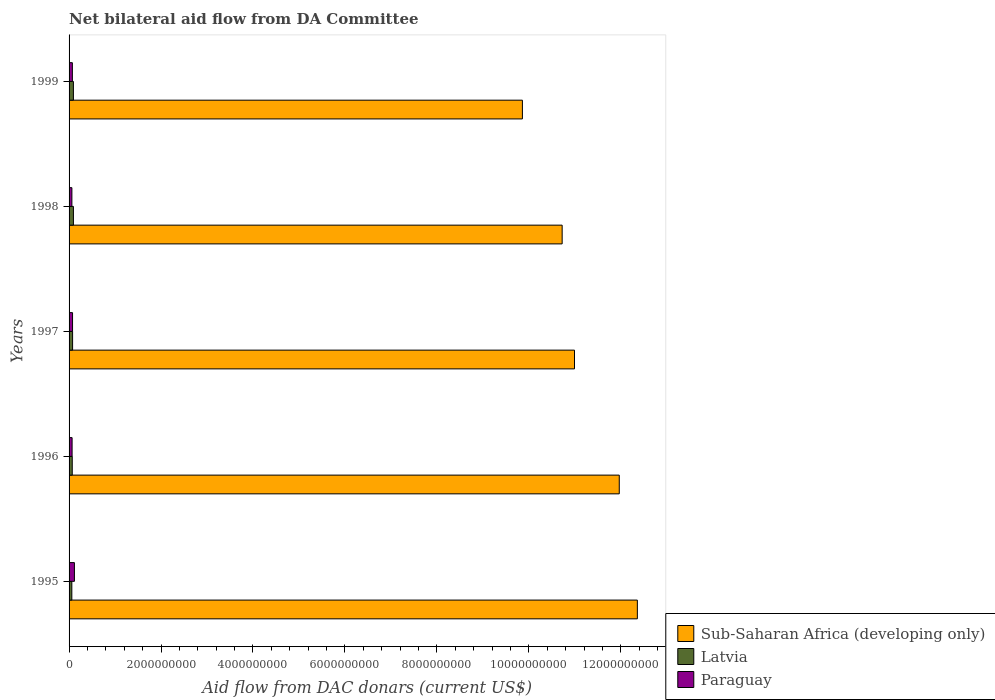How many different coloured bars are there?
Keep it short and to the point. 3. How many groups of bars are there?
Provide a short and direct response. 5. Are the number of bars on each tick of the Y-axis equal?
Your answer should be very brief. Yes. How many bars are there on the 3rd tick from the top?
Provide a short and direct response. 3. How many bars are there on the 1st tick from the bottom?
Your answer should be compact. 3. What is the aid flow in in Paraguay in 1998?
Make the answer very short. 6.14e+07. Across all years, what is the maximum aid flow in in Latvia?
Your answer should be compact. 9.46e+07. Across all years, what is the minimum aid flow in in Paraguay?
Make the answer very short. 6.14e+07. In which year was the aid flow in in Sub-Saharan Africa (developing only) maximum?
Offer a very short reply. 1995. In which year was the aid flow in in Sub-Saharan Africa (developing only) minimum?
Provide a succinct answer. 1999. What is the total aid flow in in Paraguay in the graph?
Give a very brief answer. 3.91e+08. What is the difference between the aid flow in in Paraguay in 1995 and that in 1997?
Offer a terse response. 4.06e+07. What is the difference between the aid flow in in Latvia in 1996 and the aid flow in in Sub-Saharan Africa (developing only) in 1997?
Offer a very short reply. -1.09e+1. What is the average aid flow in in Latvia per year?
Offer a very short reply. 7.90e+07. In the year 1996, what is the difference between the aid flow in in Paraguay and aid flow in in Latvia?
Offer a terse response. -3.15e+06. What is the ratio of the aid flow in in Sub-Saharan Africa (developing only) in 1995 to that in 1999?
Provide a succinct answer. 1.25. Is the aid flow in in Paraguay in 1997 less than that in 1999?
Your response must be concise. No. Is the difference between the aid flow in in Paraguay in 1995 and 1998 greater than the difference between the aid flow in in Latvia in 1995 and 1998?
Your response must be concise. Yes. What is the difference between the highest and the second highest aid flow in in Sub-Saharan Africa (developing only)?
Your response must be concise. 3.93e+08. What is the difference between the highest and the lowest aid flow in in Latvia?
Offer a terse response. 3.45e+07. What does the 2nd bar from the top in 1995 represents?
Your response must be concise. Latvia. What does the 1st bar from the bottom in 1995 represents?
Offer a very short reply. Sub-Saharan Africa (developing only). How many bars are there?
Make the answer very short. 15. Are all the bars in the graph horizontal?
Provide a succinct answer. Yes. How many years are there in the graph?
Make the answer very short. 5. Does the graph contain any zero values?
Keep it short and to the point. No. Does the graph contain grids?
Your answer should be compact. No. Where does the legend appear in the graph?
Offer a very short reply. Bottom right. How many legend labels are there?
Provide a short and direct response. 3. How are the legend labels stacked?
Offer a terse response. Vertical. What is the title of the graph?
Give a very brief answer. Net bilateral aid flow from DA Committee. Does "Uruguay" appear as one of the legend labels in the graph?
Your answer should be compact. No. What is the label or title of the X-axis?
Offer a terse response. Aid flow from DAC donars (current US$). What is the Aid flow from DAC donars (current US$) of Sub-Saharan Africa (developing only) in 1995?
Ensure brevity in your answer.  1.24e+1. What is the Aid flow from DAC donars (current US$) of Latvia in 1995?
Your answer should be very brief. 6.01e+07. What is the Aid flow from DAC donars (current US$) in Paraguay in 1995?
Offer a terse response. 1.16e+08. What is the Aid flow from DAC donars (current US$) in Sub-Saharan Africa (developing only) in 1996?
Ensure brevity in your answer.  1.20e+1. What is the Aid flow from DAC donars (current US$) in Latvia in 1996?
Make the answer very short. 6.90e+07. What is the Aid flow from DAC donars (current US$) of Paraguay in 1996?
Your answer should be very brief. 6.59e+07. What is the Aid flow from DAC donars (current US$) in Sub-Saharan Africa (developing only) in 1997?
Offer a very short reply. 1.10e+1. What is the Aid flow from DAC donars (current US$) in Latvia in 1997?
Make the answer very short. 7.67e+07. What is the Aid flow from DAC donars (current US$) of Paraguay in 1997?
Provide a short and direct response. 7.57e+07. What is the Aid flow from DAC donars (current US$) in Sub-Saharan Africa (developing only) in 1998?
Offer a terse response. 1.07e+1. What is the Aid flow from DAC donars (current US$) in Latvia in 1998?
Your answer should be very brief. 9.46e+07. What is the Aid flow from DAC donars (current US$) of Paraguay in 1998?
Make the answer very short. 6.14e+07. What is the Aid flow from DAC donars (current US$) of Sub-Saharan Africa (developing only) in 1999?
Offer a very short reply. 9.86e+09. What is the Aid flow from DAC donars (current US$) in Latvia in 1999?
Your response must be concise. 9.43e+07. What is the Aid flow from DAC donars (current US$) in Paraguay in 1999?
Give a very brief answer. 7.17e+07. Across all years, what is the maximum Aid flow from DAC donars (current US$) of Sub-Saharan Africa (developing only)?
Provide a short and direct response. 1.24e+1. Across all years, what is the maximum Aid flow from DAC donars (current US$) in Latvia?
Offer a terse response. 9.46e+07. Across all years, what is the maximum Aid flow from DAC donars (current US$) of Paraguay?
Make the answer very short. 1.16e+08. Across all years, what is the minimum Aid flow from DAC donars (current US$) of Sub-Saharan Africa (developing only)?
Provide a succinct answer. 9.86e+09. Across all years, what is the minimum Aid flow from DAC donars (current US$) of Latvia?
Your answer should be very brief. 6.01e+07. Across all years, what is the minimum Aid flow from DAC donars (current US$) of Paraguay?
Your answer should be compact. 6.14e+07. What is the total Aid flow from DAC donars (current US$) in Sub-Saharan Africa (developing only) in the graph?
Make the answer very short. 5.59e+1. What is the total Aid flow from DAC donars (current US$) in Latvia in the graph?
Offer a very short reply. 3.95e+08. What is the total Aid flow from DAC donars (current US$) of Paraguay in the graph?
Keep it short and to the point. 3.91e+08. What is the difference between the Aid flow from DAC donars (current US$) in Sub-Saharan Africa (developing only) in 1995 and that in 1996?
Your answer should be very brief. 3.93e+08. What is the difference between the Aid flow from DAC donars (current US$) in Latvia in 1995 and that in 1996?
Provide a succinct answer. -8.91e+06. What is the difference between the Aid flow from DAC donars (current US$) of Paraguay in 1995 and that in 1996?
Your response must be concise. 5.03e+07. What is the difference between the Aid flow from DAC donars (current US$) in Sub-Saharan Africa (developing only) in 1995 and that in 1997?
Offer a very short reply. 1.37e+09. What is the difference between the Aid flow from DAC donars (current US$) of Latvia in 1995 and that in 1997?
Your answer should be compact. -1.66e+07. What is the difference between the Aid flow from DAC donars (current US$) in Paraguay in 1995 and that in 1997?
Make the answer very short. 4.06e+07. What is the difference between the Aid flow from DAC donars (current US$) of Sub-Saharan Africa (developing only) in 1995 and that in 1998?
Your answer should be compact. 1.64e+09. What is the difference between the Aid flow from DAC donars (current US$) in Latvia in 1995 and that in 1998?
Offer a very short reply. -3.45e+07. What is the difference between the Aid flow from DAC donars (current US$) in Paraguay in 1995 and that in 1998?
Offer a terse response. 5.48e+07. What is the difference between the Aid flow from DAC donars (current US$) in Sub-Saharan Africa (developing only) in 1995 and that in 1999?
Your response must be concise. 2.50e+09. What is the difference between the Aid flow from DAC donars (current US$) in Latvia in 1995 and that in 1999?
Your answer should be very brief. -3.42e+07. What is the difference between the Aid flow from DAC donars (current US$) in Paraguay in 1995 and that in 1999?
Provide a short and direct response. 4.45e+07. What is the difference between the Aid flow from DAC donars (current US$) in Sub-Saharan Africa (developing only) in 1996 and that in 1997?
Keep it short and to the point. 9.74e+08. What is the difference between the Aid flow from DAC donars (current US$) in Latvia in 1996 and that in 1997?
Provide a succinct answer. -7.64e+06. What is the difference between the Aid flow from DAC donars (current US$) of Paraguay in 1996 and that in 1997?
Give a very brief answer. -9.78e+06. What is the difference between the Aid flow from DAC donars (current US$) of Sub-Saharan Africa (developing only) in 1996 and that in 1998?
Give a very brief answer. 1.24e+09. What is the difference between the Aid flow from DAC donars (current US$) of Latvia in 1996 and that in 1998?
Give a very brief answer. -2.56e+07. What is the difference between the Aid flow from DAC donars (current US$) in Paraguay in 1996 and that in 1998?
Provide a succinct answer. 4.51e+06. What is the difference between the Aid flow from DAC donars (current US$) of Sub-Saharan Africa (developing only) in 1996 and that in 1999?
Provide a succinct answer. 2.11e+09. What is the difference between the Aid flow from DAC donars (current US$) in Latvia in 1996 and that in 1999?
Keep it short and to the point. -2.53e+07. What is the difference between the Aid flow from DAC donars (current US$) in Paraguay in 1996 and that in 1999?
Provide a short and direct response. -5.84e+06. What is the difference between the Aid flow from DAC donars (current US$) in Sub-Saharan Africa (developing only) in 1997 and that in 1998?
Your answer should be very brief. 2.68e+08. What is the difference between the Aid flow from DAC donars (current US$) in Latvia in 1997 and that in 1998?
Your answer should be very brief. -1.79e+07. What is the difference between the Aid flow from DAC donars (current US$) of Paraguay in 1997 and that in 1998?
Give a very brief answer. 1.43e+07. What is the difference between the Aid flow from DAC donars (current US$) of Sub-Saharan Africa (developing only) in 1997 and that in 1999?
Offer a very short reply. 1.13e+09. What is the difference between the Aid flow from DAC donars (current US$) in Latvia in 1997 and that in 1999?
Offer a very short reply. -1.76e+07. What is the difference between the Aid flow from DAC donars (current US$) of Paraguay in 1997 and that in 1999?
Offer a terse response. 3.94e+06. What is the difference between the Aid flow from DAC donars (current US$) of Sub-Saharan Africa (developing only) in 1998 and that in 1999?
Your answer should be compact. 8.65e+08. What is the difference between the Aid flow from DAC donars (current US$) of Latvia in 1998 and that in 1999?
Make the answer very short. 2.60e+05. What is the difference between the Aid flow from DAC donars (current US$) in Paraguay in 1998 and that in 1999?
Keep it short and to the point. -1.04e+07. What is the difference between the Aid flow from DAC donars (current US$) in Sub-Saharan Africa (developing only) in 1995 and the Aid flow from DAC donars (current US$) in Latvia in 1996?
Provide a short and direct response. 1.23e+1. What is the difference between the Aid flow from DAC donars (current US$) in Sub-Saharan Africa (developing only) in 1995 and the Aid flow from DAC donars (current US$) in Paraguay in 1996?
Provide a short and direct response. 1.23e+1. What is the difference between the Aid flow from DAC donars (current US$) in Latvia in 1995 and the Aid flow from DAC donars (current US$) in Paraguay in 1996?
Give a very brief answer. -5.76e+06. What is the difference between the Aid flow from DAC donars (current US$) in Sub-Saharan Africa (developing only) in 1995 and the Aid flow from DAC donars (current US$) in Latvia in 1997?
Provide a succinct answer. 1.23e+1. What is the difference between the Aid flow from DAC donars (current US$) in Sub-Saharan Africa (developing only) in 1995 and the Aid flow from DAC donars (current US$) in Paraguay in 1997?
Your answer should be very brief. 1.23e+1. What is the difference between the Aid flow from DAC donars (current US$) in Latvia in 1995 and the Aid flow from DAC donars (current US$) in Paraguay in 1997?
Give a very brief answer. -1.55e+07. What is the difference between the Aid flow from DAC donars (current US$) of Sub-Saharan Africa (developing only) in 1995 and the Aid flow from DAC donars (current US$) of Latvia in 1998?
Your response must be concise. 1.23e+1. What is the difference between the Aid flow from DAC donars (current US$) in Sub-Saharan Africa (developing only) in 1995 and the Aid flow from DAC donars (current US$) in Paraguay in 1998?
Provide a succinct answer. 1.23e+1. What is the difference between the Aid flow from DAC donars (current US$) of Latvia in 1995 and the Aid flow from DAC donars (current US$) of Paraguay in 1998?
Provide a succinct answer. -1.25e+06. What is the difference between the Aid flow from DAC donars (current US$) in Sub-Saharan Africa (developing only) in 1995 and the Aid flow from DAC donars (current US$) in Latvia in 1999?
Keep it short and to the point. 1.23e+1. What is the difference between the Aid flow from DAC donars (current US$) in Sub-Saharan Africa (developing only) in 1995 and the Aid flow from DAC donars (current US$) in Paraguay in 1999?
Ensure brevity in your answer.  1.23e+1. What is the difference between the Aid flow from DAC donars (current US$) of Latvia in 1995 and the Aid flow from DAC donars (current US$) of Paraguay in 1999?
Keep it short and to the point. -1.16e+07. What is the difference between the Aid flow from DAC donars (current US$) of Sub-Saharan Africa (developing only) in 1996 and the Aid flow from DAC donars (current US$) of Latvia in 1997?
Your answer should be compact. 1.19e+1. What is the difference between the Aid flow from DAC donars (current US$) of Sub-Saharan Africa (developing only) in 1996 and the Aid flow from DAC donars (current US$) of Paraguay in 1997?
Provide a succinct answer. 1.19e+1. What is the difference between the Aid flow from DAC donars (current US$) of Latvia in 1996 and the Aid flow from DAC donars (current US$) of Paraguay in 1997?
Provide a succinct answer. -6.63e+06. What is the difference between the Aid flow from DAC donars (current US$) in Sub-Saharan Africa (developing only) in 1996 and the Aid flow from DAC donars (current US$) in Latvia in 1998?
Provide a succinct answer. 1.19e+1. What is the difference between the Aid flow from DAC donars (current US$) in Sub-Saharan Africa (developing only) in 1996 and the Aid flow from DAC donars (current US$) in Paraguay in 1998?
Your answer should be compact. 1.19e+1. What is the difference between the Aid flow from DAC donars (current US$) in Latvia in 1996 and the Aid flow from DAC donars (current US$) in Paraguay in 1998?
Give a very brief answer. 7.66e+06. What is the difference between the Aid flow from DAC donars (current US$) of Sub-Saharan Africa (developing only) in 1996 and the Aid flow from DAC donars (current US$) of Latvia in 1999?
Your answer should be very brief. 1.19e+1. What is the difference between the Aid flow from DAC donars (current US$) in Sub-Saharan Africa (developing only) in 1996 and the Aid flow from DAC donars (current US$) in Paraguay in 1999?
Provide a short and direct response. 1.19e+1. What is the difference between the Aid flow from DAC donars (current US$) of Latvia in 1996 and the Aid flow from DAC donars (current US$) of Paraguay in 1999?
Offer a terse response. -2.69e+06. What is the difference between the Aid flow from DAC donars (current US$) of Sub-Saharan Africa (developing only) in 1997 and the Aid flow from DAC donars (current US$) of Latvia in 1998?
Make the answer very short. 1.09e+1. What is the difference between the Aid flow from DAC donars (current US$) of Sub-Saharan Africa (developing only) in 1997 and the Aid flow from DAC donars (current US$) of Paraguay in 1998?
Provide a succinct answer. 1.09e+1. What is the difference between the Aid flow from DAC donars (current US$) of Latvia in 1997 and the Aid flow from DAC donars (current US$) of Paraguay in 1998?
Provide a short and direct response. 1.53e+07. What is the difference between the Aid flow from DAC donars (current US$) of Sub-Saharan Africa (developing only) in 1997 and the Aid flow from DAC donars (current US$) of Latvia in 1999?
Provide a short and direct response. 1.09e+1. What is the difference between the Aid flow from DAC donars (current US$) of Sub-Saharan Africa (developing only) in 1997 and the Aid flow from DAC donars (current US$) of Paraguay in 1999?
Give a very brief answer. 1.09e+1. What is the difference between the Aid flow from DAC donars (current US$) in Latvia in 1997 and the Aid flow from DAC donars (current US$) in Paraguay in 1999?
Give a very brief answer. 4.95e+06. What is the difference between the Aid flow from DAC donars (current US$) in Sub-Saharan Africa (developing only) in 1998 and the Aid flow from DAC donars (current US$) in Latvia in 1999?
Provide a short and direct response. 1.06e+1. What is the difference between the Aid flow from DAC donars (current US$) of Sub-Saharan Africa (developing only) in 1998 and the Aid flow from DAC donars (current US$) of Paraguay in 1999?
Offer a very short reply. 1.07e+1. What is the difference between the Aid flow from DAC donars (current US$) in Latvia in 1998 and the Aid flow from DAC donars (current US$) in Paraguay in 1999?
Offer a terse response. 2.29e+07. What is the average Aid flow from DAC donars (current US$) of Sub-Saharan Africa (developing only) per year?
Your answer should be very brief. 1.12e+1. What is the average Aid flow from DAC donars (current US$) in Latvia per year?
Keep it short and to the point. 7.90e+07. What is the average Aid flow from DAC donars (current US$) of Paraguay per year?
Your answer should be compact. 7.82e+07. In the year 1995, what is the difference between the Aid flow from DAC donars (current US$) of Sub-Saharan Africa (developing only) and Aid flow from DAC donars (current US$) of Latvia?
Ensure brevity in your answer.  1.23e+1. In the year 1995, what is the difference between the Aid flow from DAC donars (current US$) of Sub-Saharan Africa (developing only) and Aid flow from DAC donars (current US$) of Paraguay?
Your answer should be compact. 1.22e+1. In the year 1995, what is the difference between the Aid flow from DAC donars (current US$) in Latvia and Aid flow from DAC donars (current US$) in Paraguay?
Your answer should be compact. -5.61e+07. In the year 1996, what is the difference between the Aid flow from DAC donars (current US$) of Sub-Saharan Africa (developing only) and Aid flow from DAC donars (current US$) of Latvia?
Provide a short and direct response. 1.19e+1. In the year 1996, what is the difference between the Aid flow from DAC donars (current US$) in Sub-Saharan Africa (developing only) and Aid flow from DAC donars (current US$) in Paraguay?
Offer a very short reply. 1.19e+1. In the year 1996, what is the difference between the Aid flow from DAC donars (current US$) in Latvia and Aid flow from DAC donars (current US$) in Paraguay?
Your answer should be very brief. 3.15e+06. In the year 1997, what is the difference between the Aid flow from DAC donars (current US$) in Sub-Saharan Africa (developing only) and Aid flow from DAC donars (current US$) in Latvia?
Ensure brevity in your answer.  1.09e+1. In the year 1997, what is the difference between the Aid flow from DAC donars (current US$) of Sub-Saharan Africa (developing only) and Aid flow from DAC donars (current US$) of Paraguay?
Give a very brief answer. 1.09e+1. In the year 1997, what is the difference between the Aid flow from DAC donars (current US$) in Latvia and Aid flow from DAC donars (current US$) in Paraguay?
Provide a short and direct response. 1.01e+06. In the year 1998, what is the difference between the Aid flow from DAC donars (current US$) in Sub-Saharan Africa (developing only) and Aid flow from DAC donars (current US$) in Latvia?
Offer a very short reply. 1.06e+1. In the year 1998, what is the difference between the Aid flow from DAC donars (current US$) of Sub-Saharan Africa (developing only) and Aid flow from DAC donars (current US$) of Paraguay?
Keep it short and to the point. 1.07e+1. In the year 1998, what is the difference between the Aid flow from DAC donars (current US$) of Latvia and Aid flow from DAC donars (current US$) of Paraguay?
Provide a short and direct response. 3.32e+07. In the year 1999, what is the difference between the Aid flow from DAC donars (current US$) in Sub-Saharan Africa (developing only) and Aid flow from DAC donars (current US$) in Latvia?
Your answer should be very brief. 9.77e+09. In the year 1999, what is the difference between the Aid flow from DAC donars (current US$) in Sub-Saharan Africa (developing only) and Aid flow from DAC donars (current US$) in Paraguay?
Your response must be concise. 9.79e+09. In the year 1999, what is the difference between the Aid flow from DAC donars (current US$) of Latvia and Aid flow from DAC donars (current US$) of Paraguay?
Your answer should be compact. 2.26e+07. What is the ratio of the Aid flow from DAC donars (current US$) of Sub-Saharan Africa (developing only) in 1995 to that in 1996?
Offer a very short reply. 1.03. What is the ratio of the Aid flow from DAC donars (current US$) of Latvia in 1995 to that in 1996?
Give a very brief answer. 0.87. What is the ratio of the Aid flow from DAC donars (current US$) in Paraguay in 1995 to that in 1996?
Make the answer very short. 1.76. What is the ratio of the Aid flow from DAC donars (current US$) in Sub-Saharan Africa (developing only) in 1995 to that in 1997?
Ensure brevity in your answer.  1.12. What is the ratio of the Aid flow from DAC donars (current US$) of Latvia in 1995 to that in 1997?
Ensure brevity in your answer.  0.78. What is the ratio of the Aid flow from DAC donars (current US$) in Paraguay in 1995 to that in 1997?
Provide a succinct answer. 1.54. What is the ratio of the Aid flow from DAC donars (current US$) in Sub-Saharan Africa (developing only) in 1995 to that in 1998?
Offer a very short reply. 1.15. What is the ratio of the Aid flow from DAC donars (current US$) of Latvia in 1995 to that in 1998?
Your answer should be very brief. 0.64. What is the ratio of the Aid flow from DAC donars (current US$) in Paraguay in 1995 to that in 1998?
Keep it short and to the point. 1.89. What is the ratio of the Aid flow from DAC donars (current US$) of Sub-Saharan Africa (developing only) in 1995 to that in 1999?
Provide a short and direct response. 1.25. What is the ratio of the Aid flow from DAC donars (current US$) in Latvia in 1995 to that in 1999?
Offer a terse response. 0.64. What is the ratio of the Aid flow from DAC donars (current US$) in Paraguay in 1995 to that in 1999?
Keep it short and to the point. 1.62. What is the ratio of the Aid flow from DAC donars (current US$) in Sub-Saharan Africa (developing only) in 1996 to that in 1997?
Provide a succinct answer. 1.09. What is the ratio of the Aid flow from DAC donars (current US$) in Latvia in 1996 to that in 1997?
Provide a succinct answer. 0.9. What is the ratio of the Aid flow from DAC donars (current US$) in Paraguay in 1996 to that in 1997?
Keep it short and to the point. 0.87. What is the ratio of the Aid flow from DAC donars (current US$) in Sub-Saharan Africa (developing only) in 1996 to that in 1998?
Ensure brevity in your answer.  1.12. What is the ratio of the Aid flow from DAC donars (current US$) in Latvia in 1996 to that in 1998?
Give a very brief answer. 0.73. What is the ratio of the Aid flow from DAC donars (current US$) in Paraguay in 1996 to that in 1998?
Make the answer very short. 1.07. What is the ratio of the Aid flow from DAC donars (current US$) in Sub-Saharan Africa (developing only) in 1996 to that in 1999?
Your response must be concise. 1.21. What is the ratio of the Aid flow from DAC donars (current US$) of Latvia in 1996 to that in 1999?
Make the answer very short. 0.73. What is the ratio of the Aid flow from DAC donars (current US$) in Paraguay in 1996 to that in 1999?
Offer a terse response. 0.92. What is the ratio of the Aid flow from DAC donars (current US$) in Sub-Saharan Africa (developing only) in 1997 to that in 1998?
Keep it short and to the point. 1.02. What is the ratio of the Aid flow from DAC donars (current US$) of Latvia in 1997 to that in 1998?
Your answer should be compact. 0.81. What is the ratio of the Aid flow from DAC donars (current US$) of Paraguay in 1997 to that in 1998?
Offer a very short reply. 1.23. What is the ratio of the Aid flow from DAC donars (current US$) of Sub-Saharan Africa (developing only) in 1997 to that in 1999?
Your answer should be compact. 1.11. What is the ratio of the Aid flow from DAC donars (current US$) in Latvia in 1997 to that in 1999?
Keep it short and to the point. 0.81. What is the ratio of the Aid flow from DAC donars (current US$) of Paraguay in 1997 to that in 1999?
Offer a very short reply. 1.05. What is the ratio of the Aid flow from DAC donars (current US$) of Sub-Saharan Africa (developing only) in 1998 to that in 1999?
Your response must be concise. 1.09. What is the ratio of the Aid flow from DAC donars (current US$) of Latvia in 1998 to that in 1999?
Your response must be concise. 1. What is the ratio of the Aid flow from DAC donars (current US$) in Paraguay in 1998 to that in 1999?
Keep it short and to the point. 0.86. What is the difference between the highest and the second highest Aid flow from DAC donars (current US$) in Sub-Saharan Africa (developing only)?
Your answer should be compact. 3.93e+08. What is the difference between the highest and the second highest Aid flow from DAC donars (current US$) of Paraguay?
Give a very brief answer. 4.06e+07. What is the difference between the highest and the lowest Aid flow from DAC donars (current US$) of Sub-Saharan Africa (developing only)?
Provide a succinct answer. 2.50e+09. What is the difference between the highest and the lowest Aid flow from DAC donars (current US$) of Latvia?
Provide a short and direct response. 3.45e+07. What is the difference between the highest and the lowest Aid flow from DAC donars (current US$) of Paraguay?
Provide a short and direct response. 5.48e+07. 